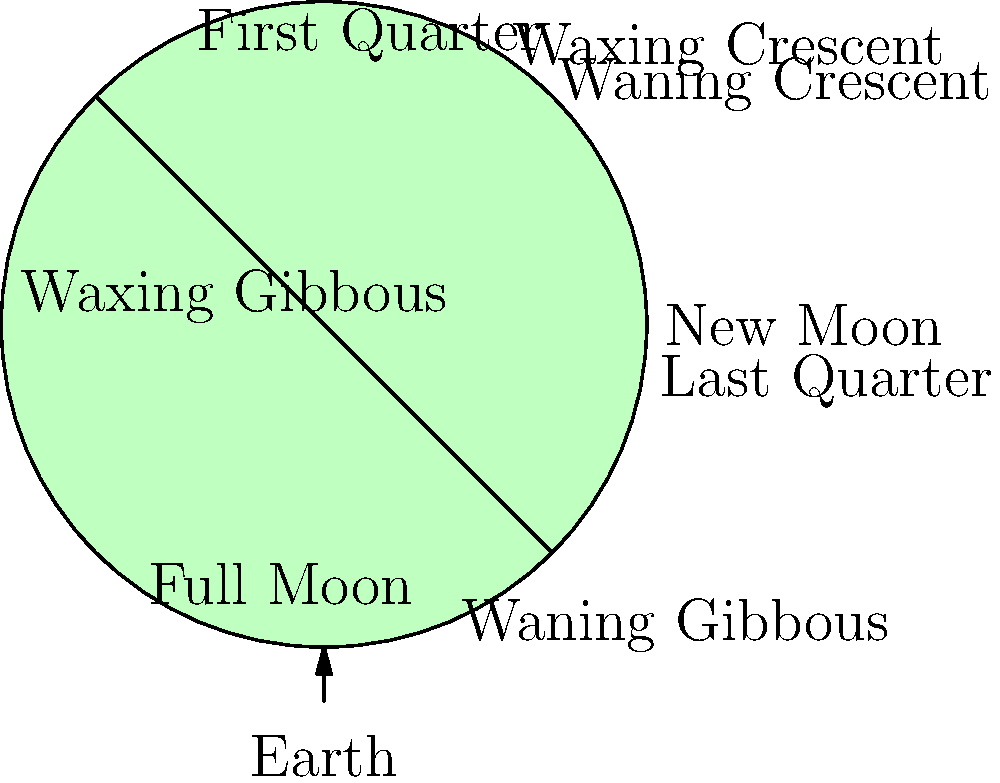As a cognitive neuroscientist studying the effects of extreme environments on the brain, you're designing an experiment to assess how lunar phases might influence cognitive performance in astronauts during long-term space missions. Given the diagram of lunar phases as seen from Earth, which phase would provide the most illumination for nighttime cognitive tasks on the lunar surface, and how might this impact circadian rhythms and cognitive function? To answer this question, we need to consider the following steps:

1. Lunar phase illumination:
   - The Full Moon provides the most illumination as seen from Earth.
   - This is because the entire visible surface of the Moon is reflecting sunlight towards Earth.

2. Lunar surface illumination:
   - On the lunar surface, the "Full Moon" phase actually corresponds to lunar noon.
   - During this phase, the Sun is directly overhead on the lunar surface.

3. Impact on circadian rhythms:
   - Circadian rhythms are influenced by light exposure.
   - The lack of atmospheric scattering on the Moon means more intense light during lunar day.
   - This intense light could disrupt natural circadian rhythms if not properly managed.

4. Cognitive function considerations:
   - Bright light can increase alertness and cognitive performance in the short term.
   - However, prolonged exposure to intense light without proper dark periods can lead to sleep disturbances and cognitive impairment.

5. Experiment design implications:
   - Nighttime cognitive tasks on the lunar surface would be best performed during the "New Moon" phase as seen from Earth.
   - This corresponds to lunar night, providing darkness for sleep regulation.
   - Artificial lighting could be used to simulate Earth-like day-night cycles.

6. Cognitive neuroscience perspective:
   - The experiment should measure cognitive performance across different lunar phases.
   - Factors to consider: attention, memory, decision-making, and reaction time.
   - Monitoring of sleep patterns and melatonin levels would be crucial.

In conclusion, while the Full Moon provides the most illumination from Earth's perspective, it's actually the New Moon phase that would be most suitable for nighttime cognitive tasks on the lunar surface, as it corresponds to lunar night.
Answer: New Moon phase, corresponding to lunar night, is optimal for nighttime cognitive tasks on the lunar surface. 